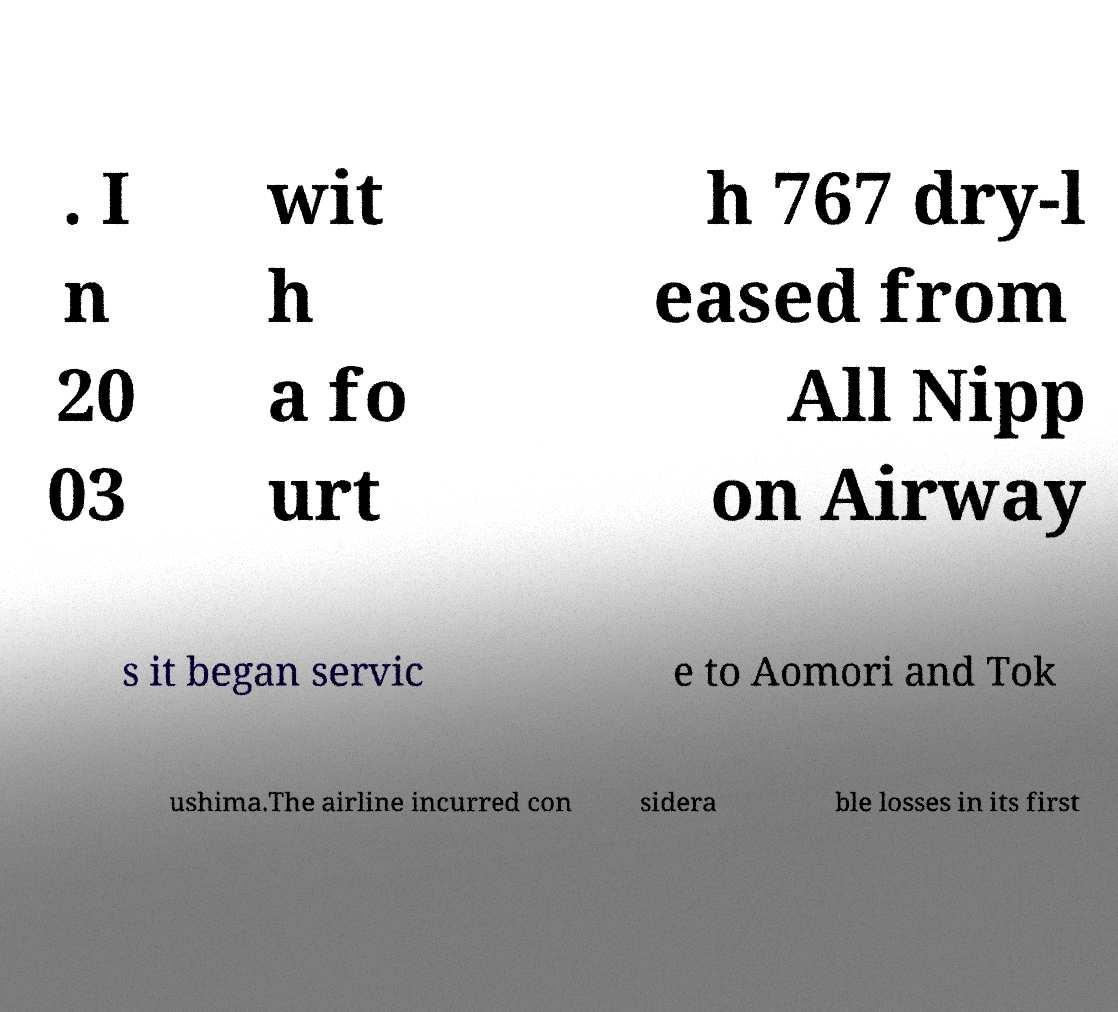Please read and relay the text visible in this image. What does it say? . I n 20 03 wit h a fo urt h 767 dry-l eased from All Nipp on Airway s it began servic e to Aomori and Tok ushima.The airline incurred con sidera ble losses in its first 